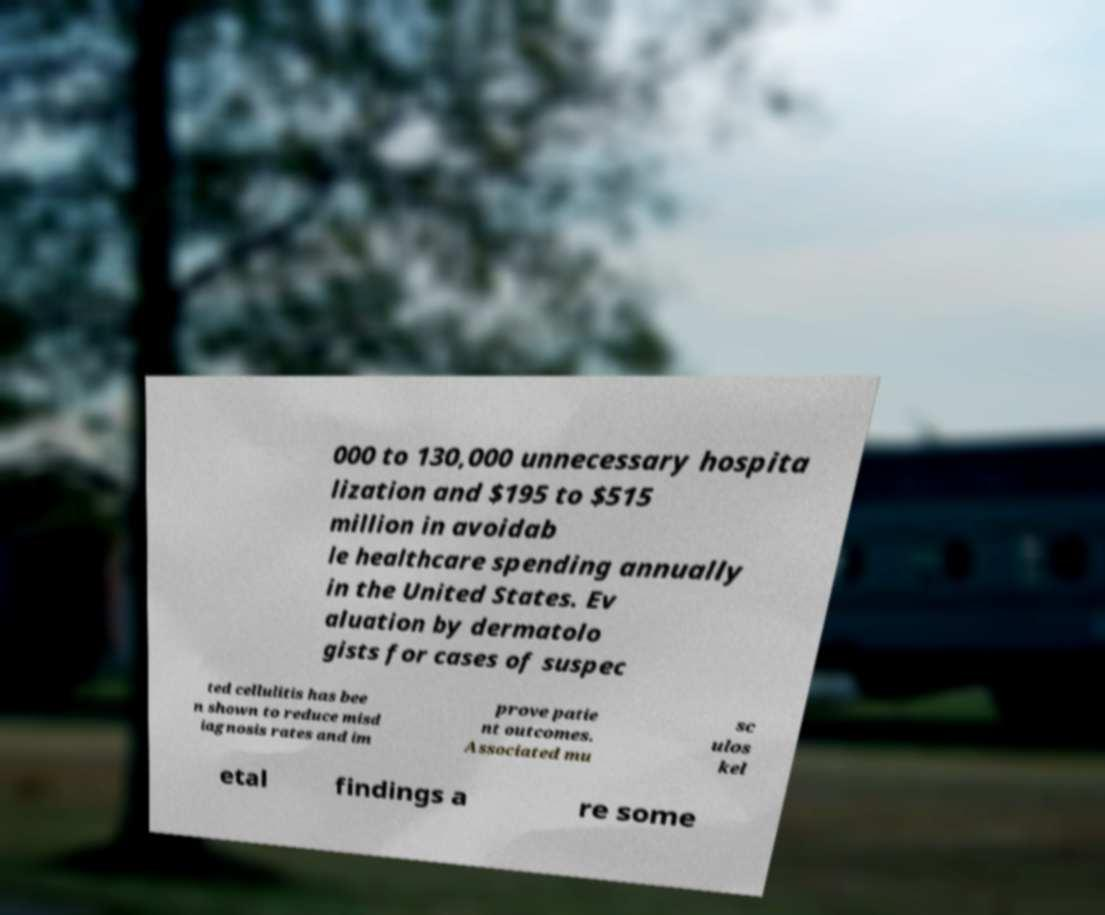Please read and relay the text visible in this image. What does it say? 000 to 130,000 unnecessary hospita lization and $195 to $515 million in avoidab le healthcare spending annually in the United States. Ev aluation by dermatolo gists for cases of suspec ted cellulitis has bee n shown to reduce misd iagnosis rates and im prove patie nt outcomes. Associated mu sc ulos kel etal findings a re some 